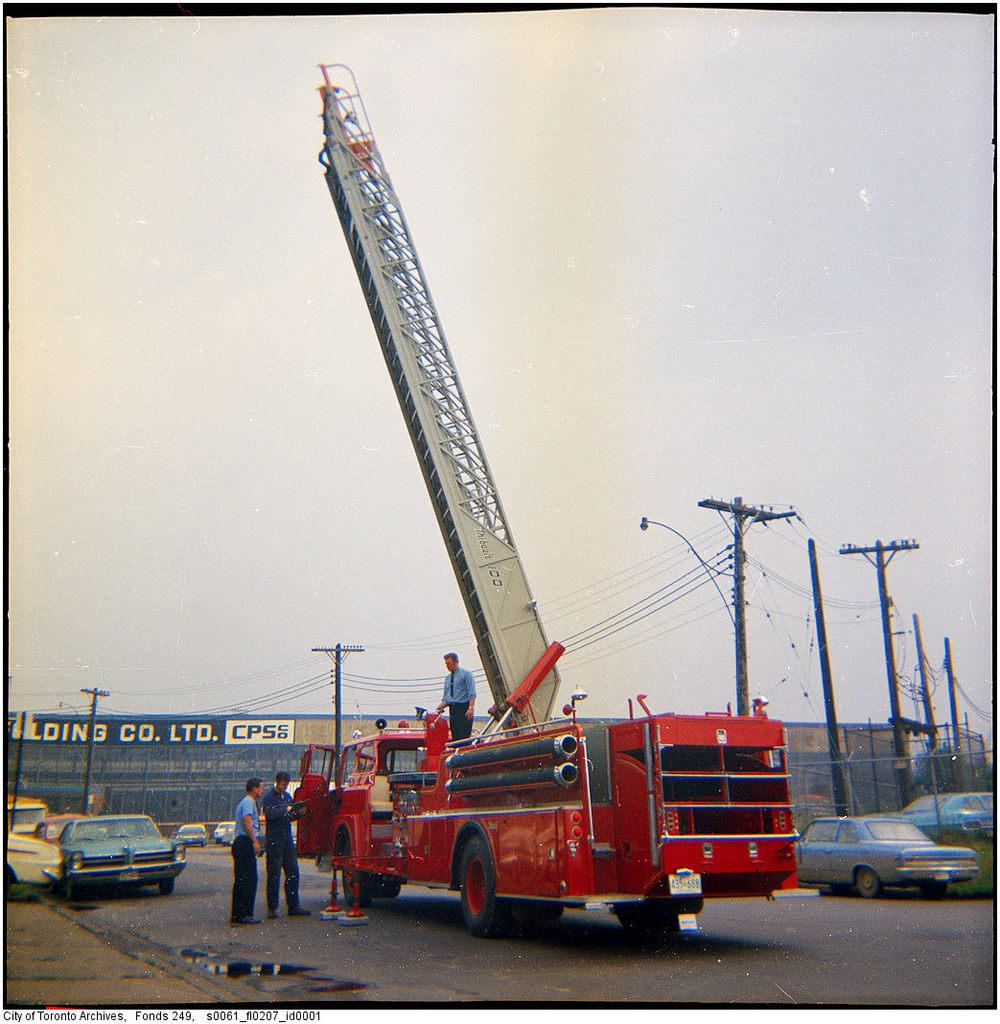Who or what can be seen in the image? There are people in the image. What organization is represented in the image? A fire brigade is present in the image. What type of objects are visible in the image? There are vehicles in the image. What structures can be seen in the image? Electrical poles are visible in the image. What additional information is provided in the image? There is a poster with text in the image. What is visible in the background of the image? The sky is visible in the image. What type of watch can be seen on the firefighter's wrist in the image? There is no watch visible on anyone's wrist in the image. What kind of twig is being used by the firefighters to extinguish the fire in the image? There is no twig being used in the image; firefighters typically use hoses or other specialized equipment to extinguish fires. 